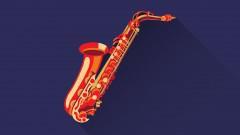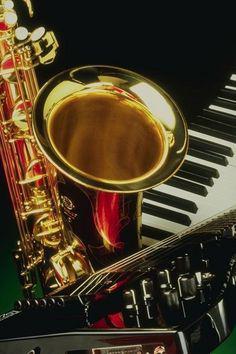The first image is the image on the left, the second image is the image on the right. Analyze the images presented: Is the assertion "There are exactly two saxophones." valid? Answer yes or no. Yes. The first image is the image on the left, the second image is the image on the right. Evaluate the accuracy of this statement regarding the images: "One image contains a single gold saxophone with its mouthpiece at the top, and the other image shows three saxophones, at least two of them with curved bell ends.". Is it true? Answer yes or no. No. 